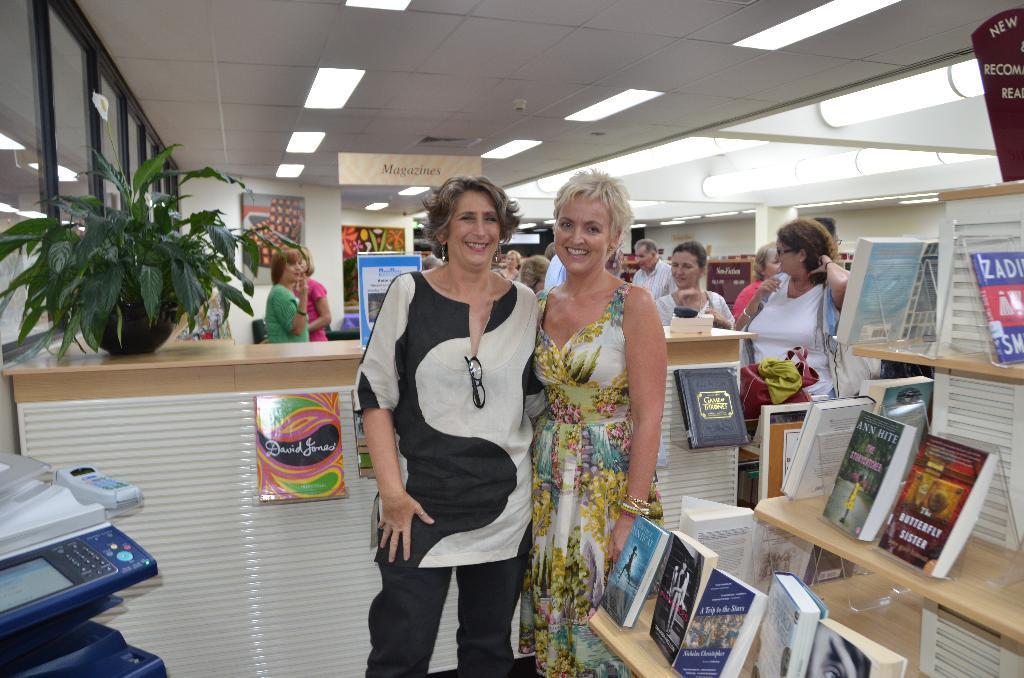In one or two sentences, can you explain what this image depicts? In this image there are two persons standing together in front of table, beside them there is a shelf with so many books in it, also there are so many lights in the roof. 